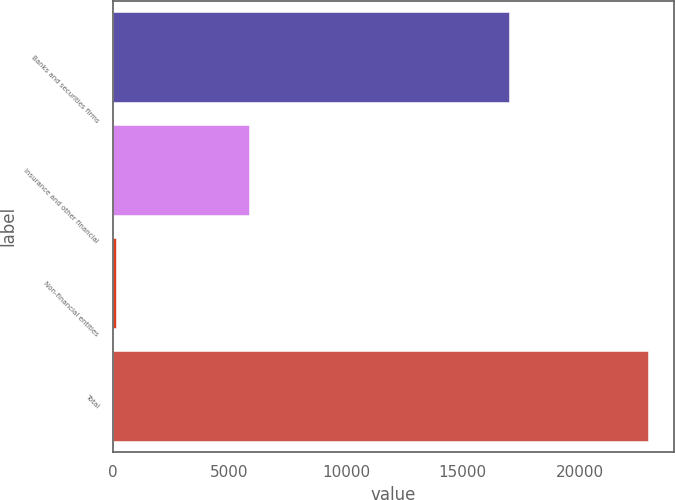<chart> <loc_0><loc_0><loc_500><loc_500><bar_chart><fcel>Banks and securities firms<fcel>Insurance and other financial<fcel>Non-financial entities<fcel>Total<nl><fcel>16962<fcel>5842<fcel>115<fcel>22919<nl></chart> 